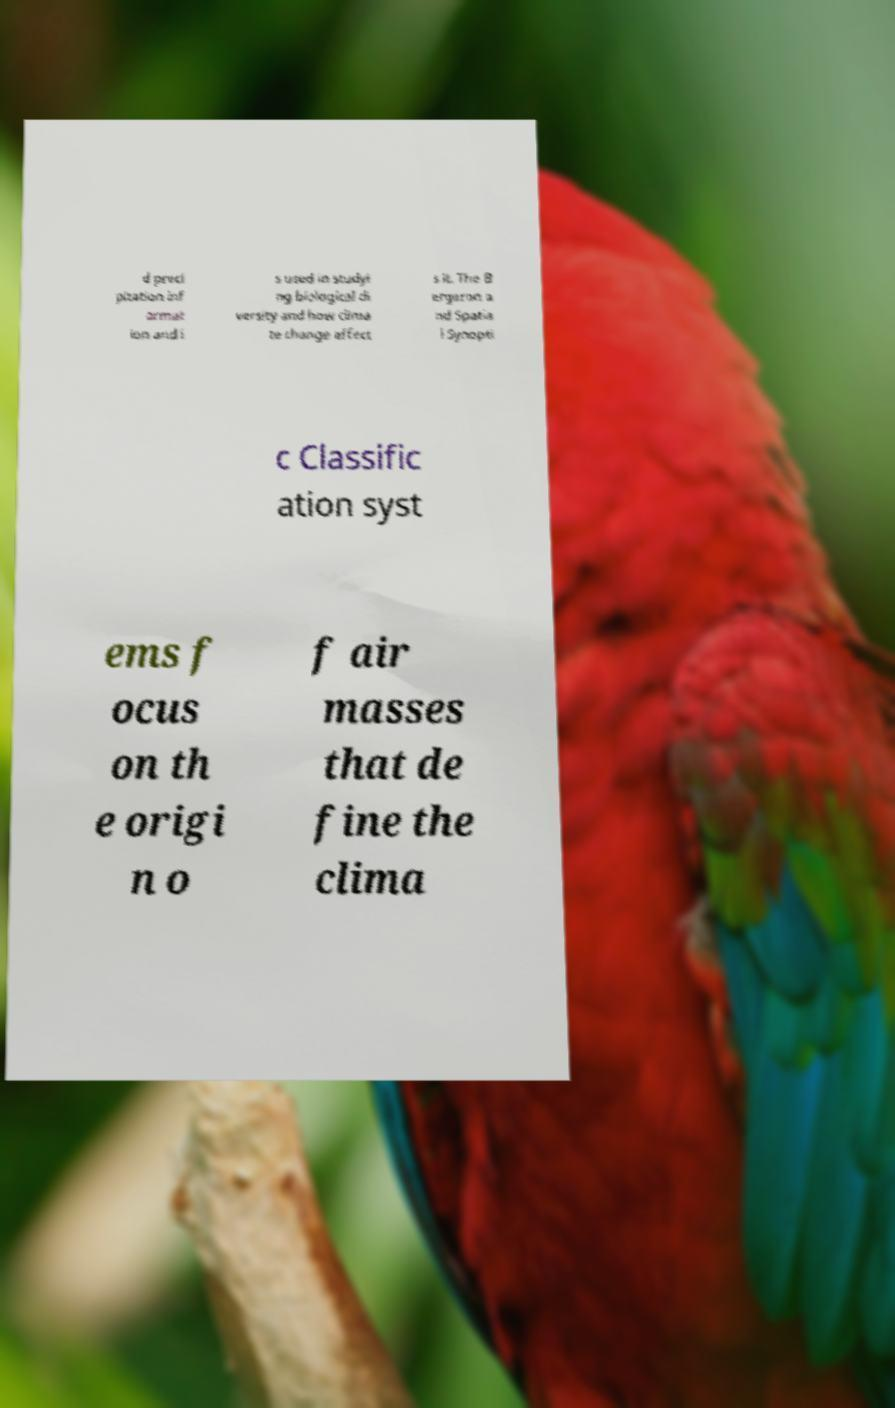Please read and relay the text visible in this image. What does it say? d preci pitation inf ormat ion and i s used in studyi ng biological di versity and how clima te change affect s it. The B ergeron a nd Spatia l Synopti c Classific ation syst ems f ocus on th e origi n o f air masses that de fine the clima 